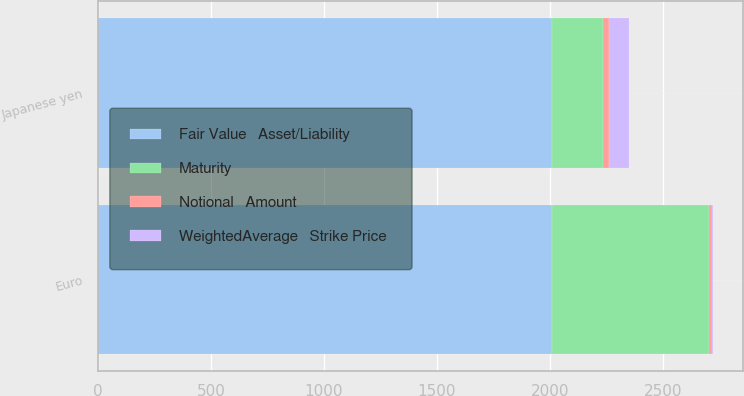<chart> <loc_0><loc_0><loc_500><loc_500><stacked_bar_chart><ecel><fcel>Euro<fcel>Japanese yen<nl><fcel>WeightedAverage   Strike Price<fcel>1.36<fcel>89.87<nl><fcel>Maturity<fcel>695<fcel>226<nl><fcel>Notional   Amount<fcel>13<fcel>25<nl><fcel>Fair Value   Asset/Liability<fcel>2011<fcel>2011<nl></chart> 